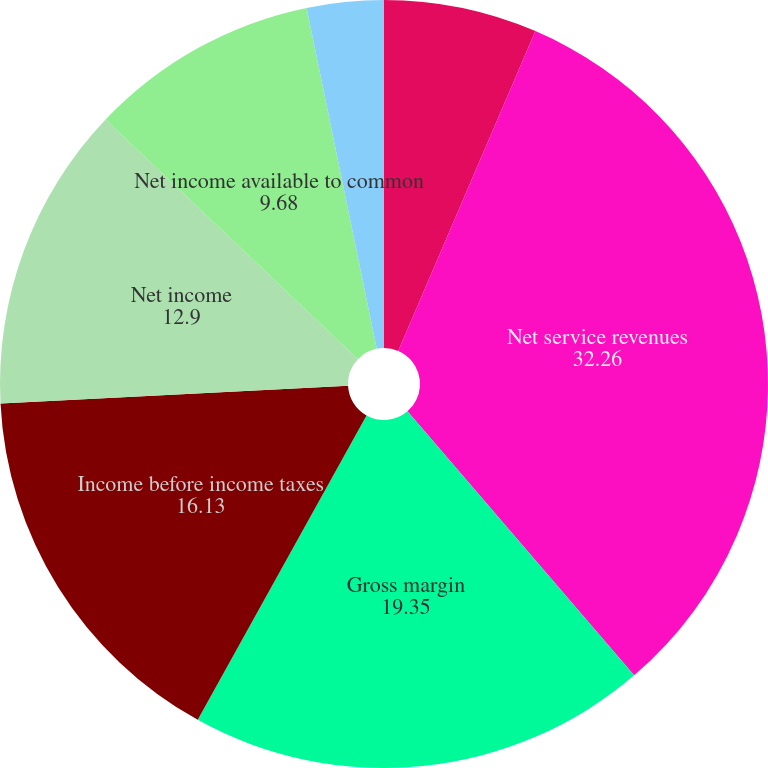Convert chart. <chart><loc_0><loc_0><loc_500><loc_500><pie_chart><fcel>2011<fcel>Net service revenues<fcel>Gross margin<fcel>Income before income taxes<fcel>Net income<fcel>Net income available to common<fcel>Basic net income per share<fcel>Diluted net income per share<nl><fcel>6.45%<fcel>32.26%<fcel>19.35%<fcel>16.13%<fcel>12.9%<fcel>9.68%<fcel>0.0%<fcel>3.23%<nl></chart> 